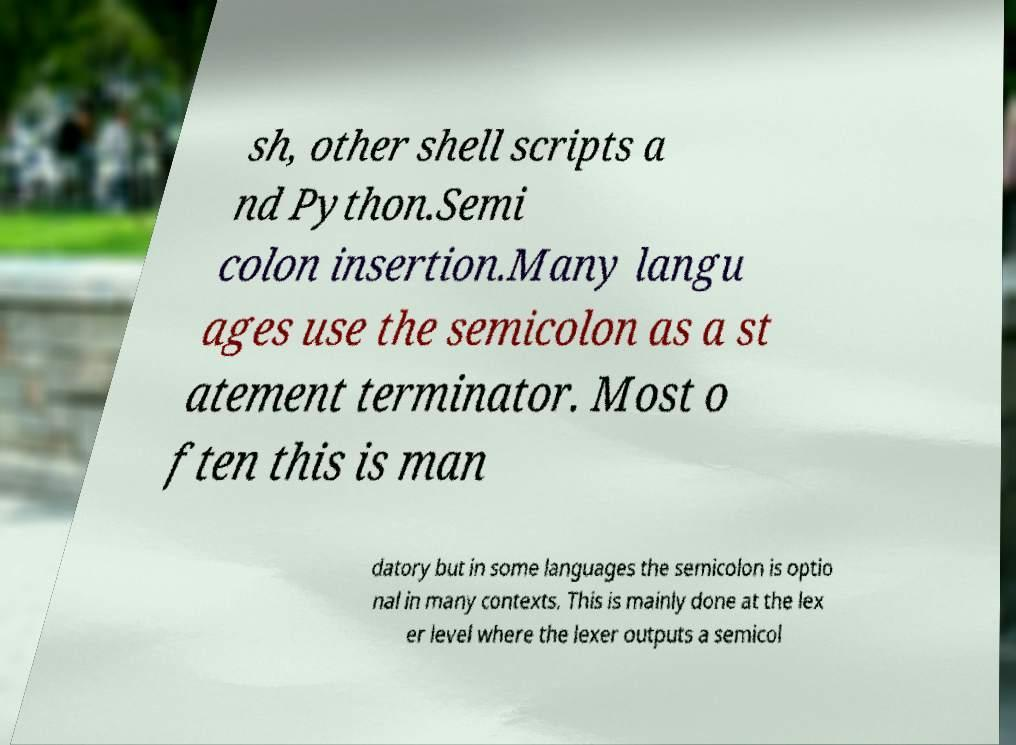Please read and relay the text visible in this image. What does it say? sh, other shell scripts a nd Python.Semi colon insertion.Many langu ages use the semicolon as a st atement terminator. Most o ften this is man datory but in some languages the semicolon is optio nal in many contexts. This is mainly done at the lex er level where the lexer outputs a semicol 